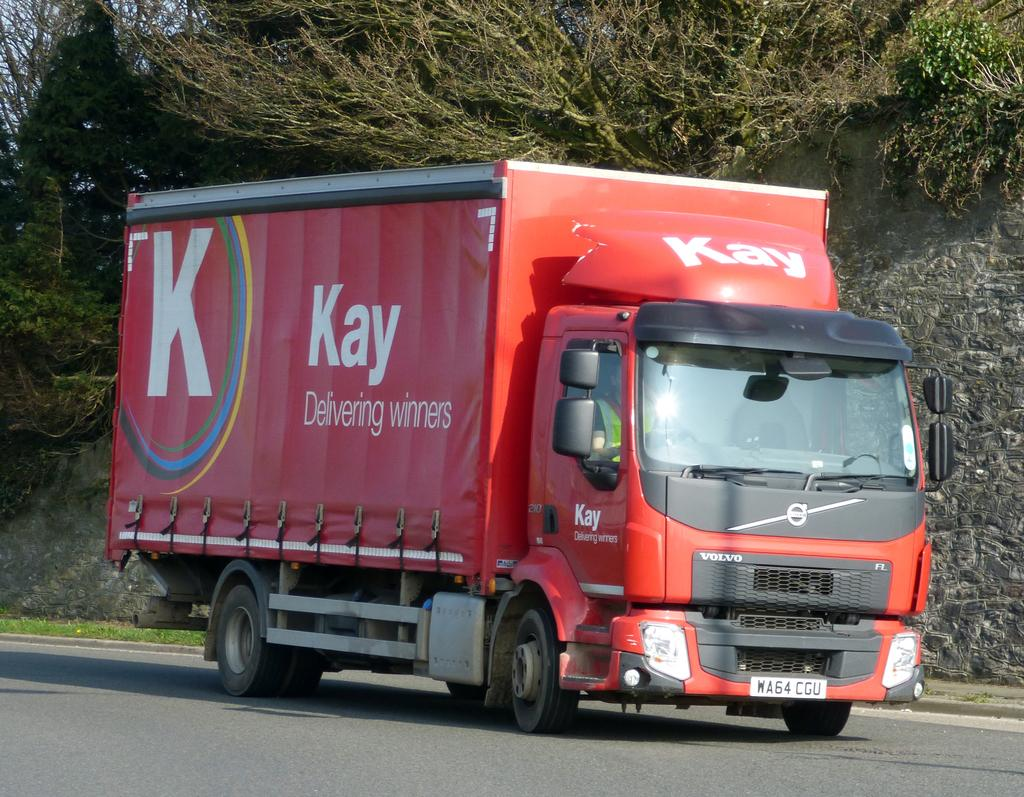What type of vehicle is in the image? There is a red truck in the image. Where is the truck located? The truck is on the road. What natural elements can be seen in the image? There are trees and grass in the image. What disease is the truck suffering from in the image? There is no indication of any disease in the image; it is a red truck on the road. How many thumbs can be seen on the truck in the image? There are no thumbs present in the image, as it features a truck and not a person. 